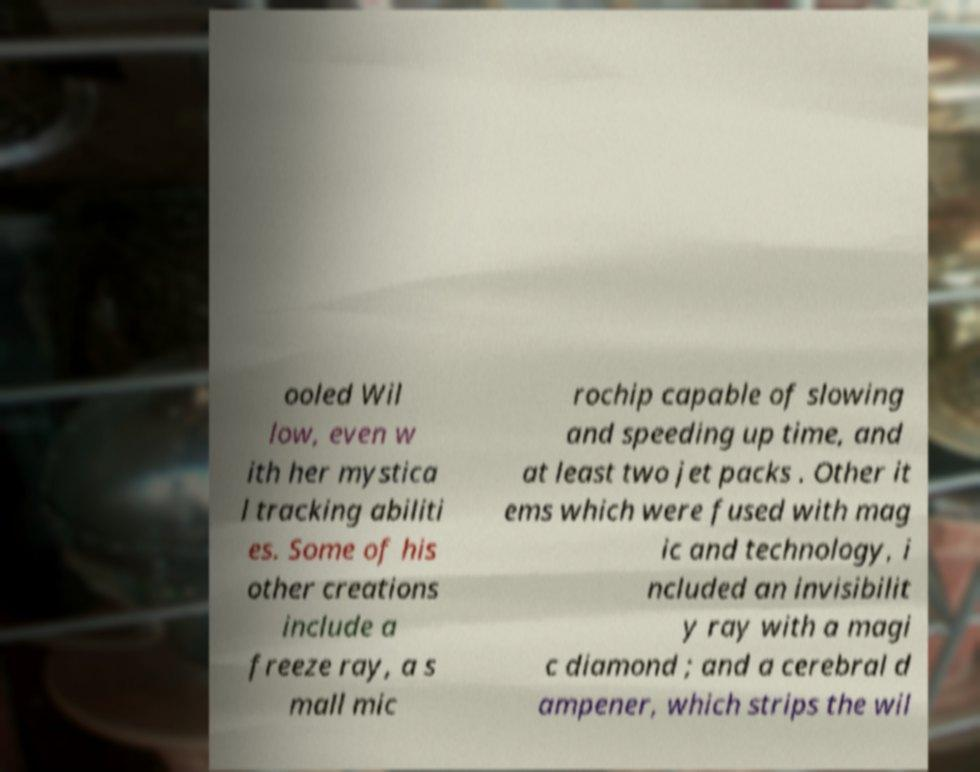Can you read and provide the text displayed in the image?This photo seems to have some interesting text. Can you extract and type it out for me? ooled Wil low, even w ith her mystica l tracking abiliti es. Some of his other creations include a freeze ray, a s mall mic rochip capable of slowing and speeding up time, and at least two jet packs . Other it ems which were fused with mag ic and technology, i ncluded an invisibilit y ray with a magi c diamond ; and a cerebral d ampener, which strips the wil 